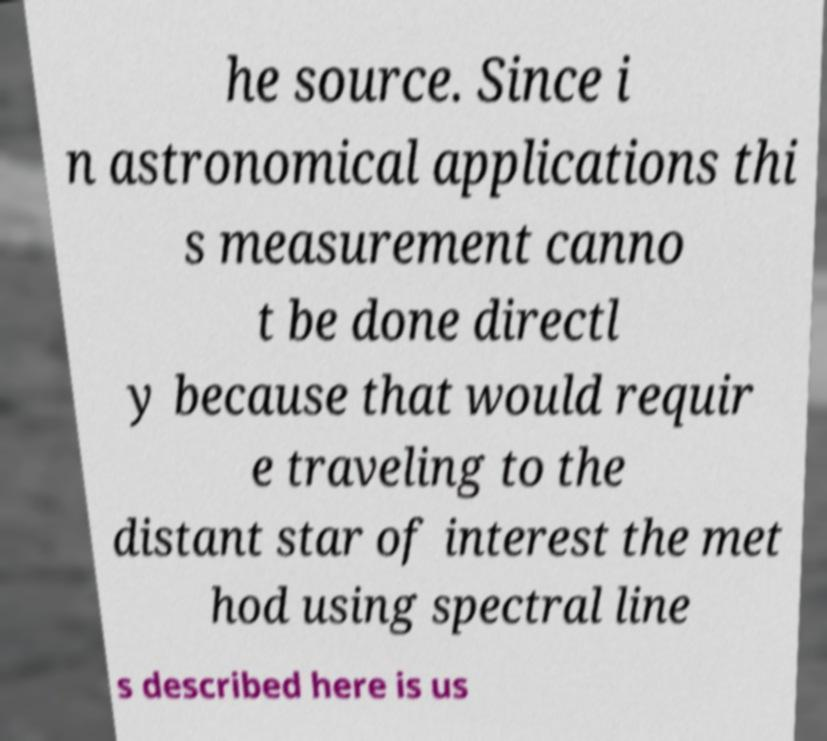Please identify and transcribe the text found in this image. he source. Since i n astronomical applications thi s measurement canno t be done directl y because that would requir e traveling to the distant star of interest the met hod using spectral line s described here is us 